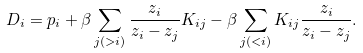Convert formula to latex. <formula><loc_0><loc_0><loc_500><loc_500>D _ { i } = p _ { i } + \beta \sum _ { j ( > i ) } \frac { z _ { i } } { z _ { i } - z _ { j } } K _ { i j } - \beta \sum _ { j ( < i ) } K _ { i j } \frac { z _ { i } } { z _ { i } - z _ { j } } .</formula> 